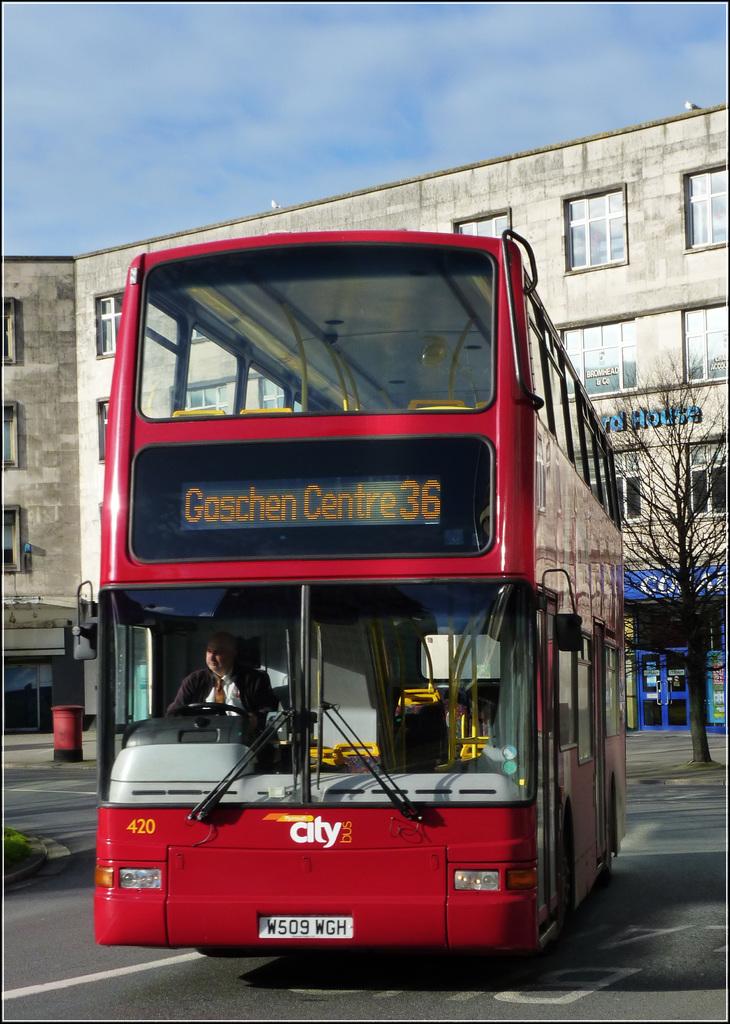Where is the bus route going?
Offer a very short reply. Goschen centre. Which route number is this?
Keep it short and to the point. 36. 